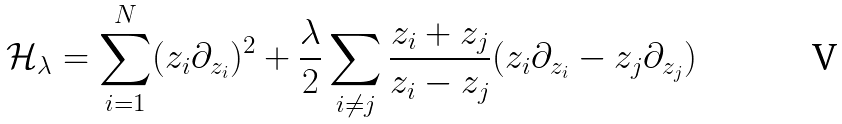Convert formula to latex. <formula><loc_0><loc_0><loc_500><loc_500>\mathcal { H } _ { \lambda } = \sum ^ { N } _ { i = 1 } ( z _ { i } \partial _ { z _ { i } } ) ^ { 2 } + \frac { \lambda } { 2 } \sum _ { i \neq j } \frac { z _ { i } + z _ { j } } { z _ { i } - z _ { j } } ( z _ { i } \partial _ { z _ { i } } - z _ { j } \partial _ { z _ { j } } )</formula> 